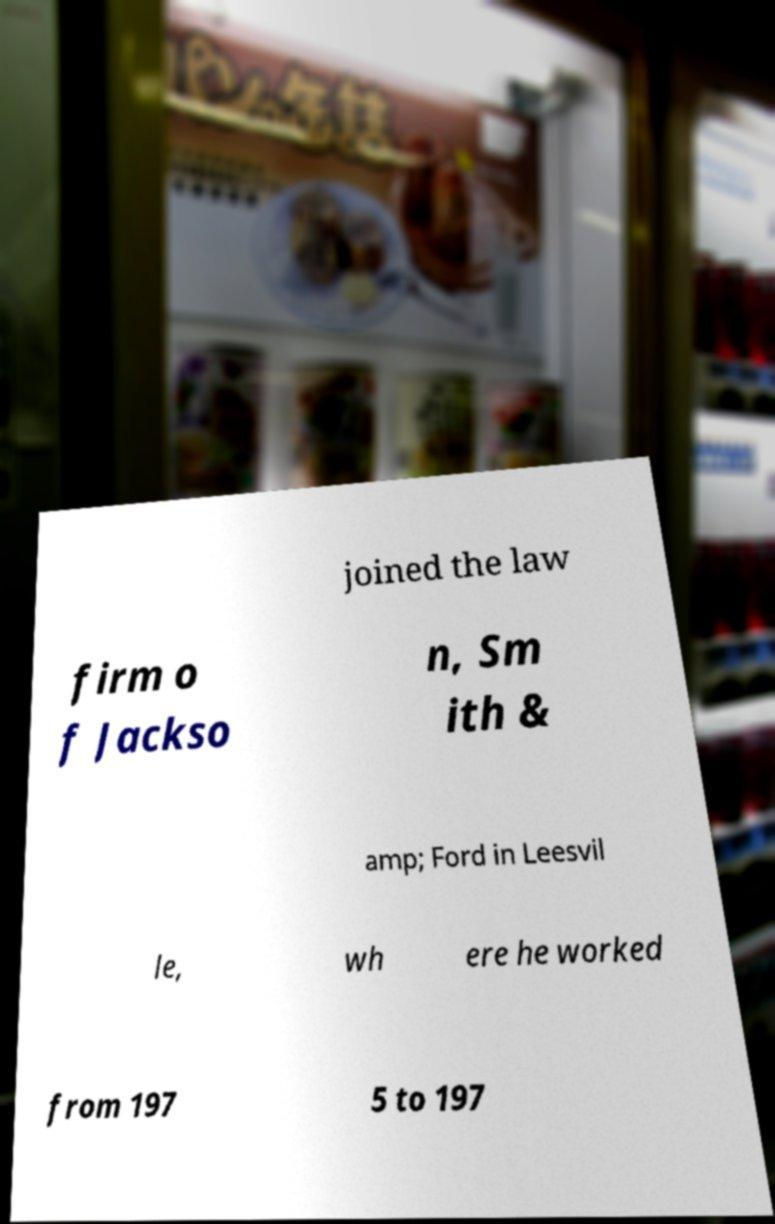Please read and relay the text visible in this image. What does it say? joined the law firm o f Jackso n, Sm ith & amp; Ford in Leesvil le, wh ere he worked from 197 5 to 197 